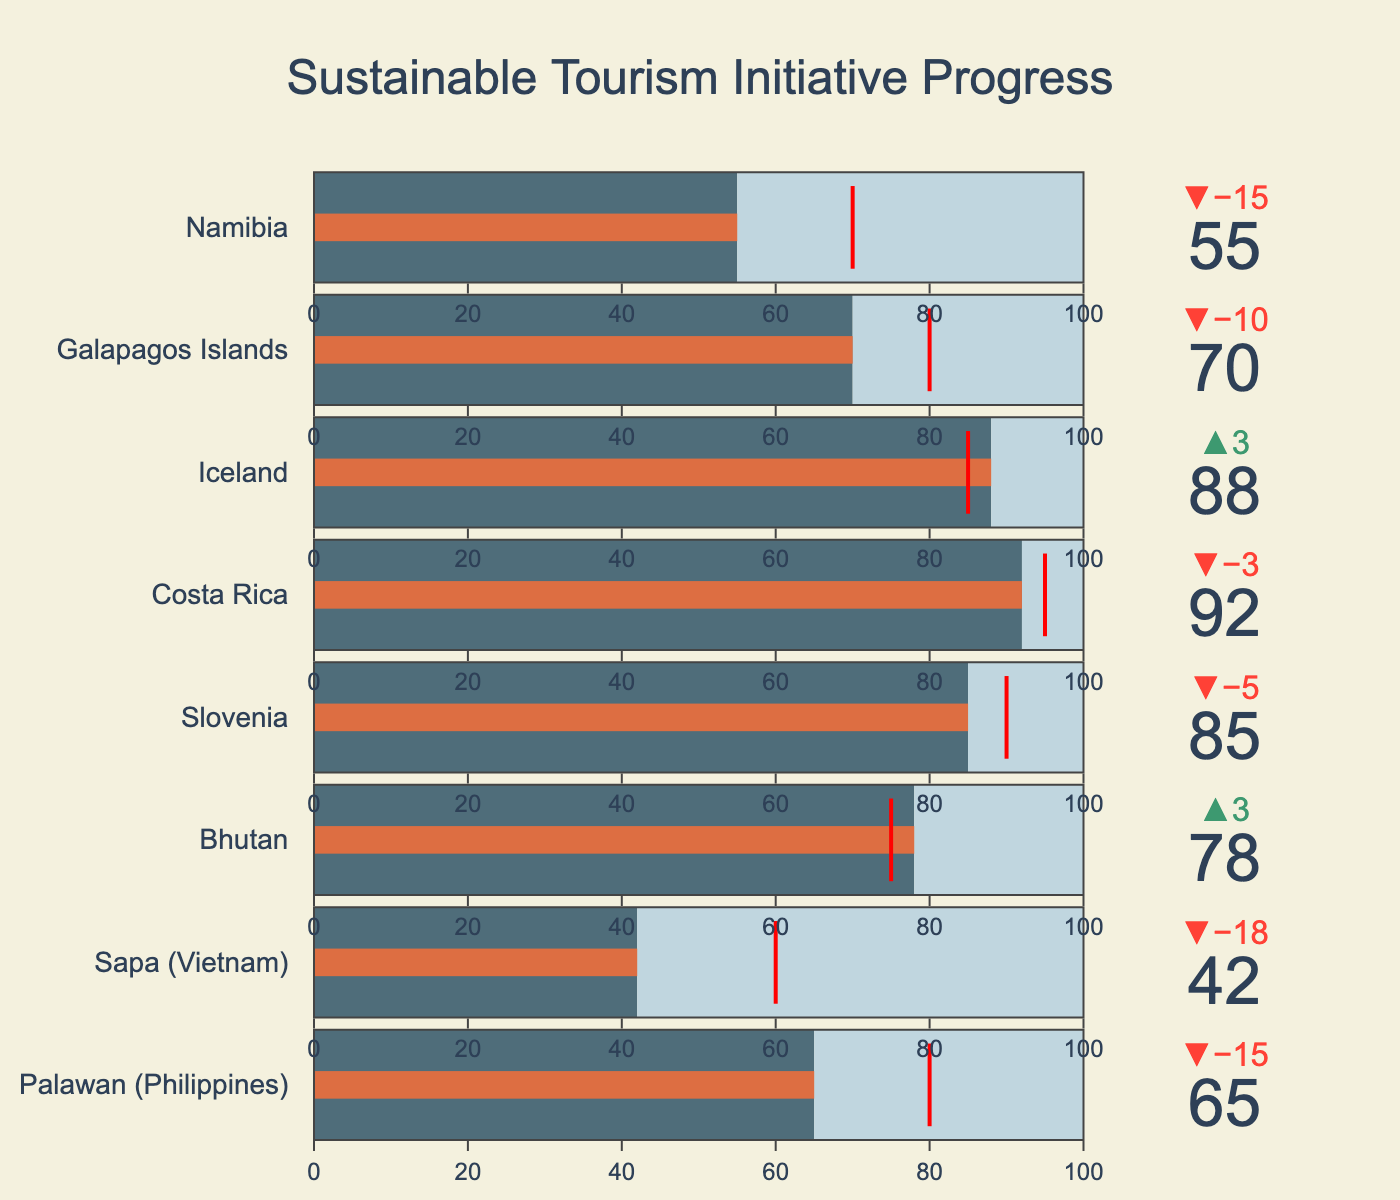What's the title of the chart? The title of the chart is typically displayed prominently at the top. By looking at the figure, the title is given as "Sustainable Tourism Initiative Progress".
Answer: Sustainable Tourism Initiative Progress Which destination has the highest actual progress? By examining the values of actual progress for each destination, Costa Rica has the highest actual progress at 92.
Answer: Costa Rica Which destination did not meet its target? Destinations that did not meet their targets have actual progress values less than their target values. These destinations are Palawan, Sapa, Galapagos Islands, and Namibia.
Answer: Palawan, Sapa, Galapagos Islands, Namibia How much more progress does Palawan need to meet its target? The progress Palawan needs to meet its target is the difference between the target and the actual progress. Therefore, it's 80 - 65 = 15.
Answer: 15 What is the average target value across all destinations? The target values are 80, 60, 75, 90, 95, 85, 80, and 70. Their sum is 635, and there are 8 destinations. So, the average target is 635 / 8 = 79.375.
Answer: 79.375 Which destination exceeds its target by the largest margin? By comparing actual progress to target values, the destination exceeding its target by the largest margin is Iceland, with an actual progress of 88 compared to a target of 85. The difference is 3.
Answer: Iceland By how much did Bhutan exceed its target? The difference between Bhutan's actual progress (78) and its target (75) is 78 - 75 = 3.
Answer: 3 Arrange the destinations in descending order of actual progress. The destinations can be ordered by their actual progress values as follows: Costa Rica (92), Iceland (88), Slovenia (85), Bhutan (78), Galapagos Islands (70), Palawan (65), Namibia (55), Sapa (42).
Answer: Costa Rica, Iceland, Slovenia, Bhutan, Galapagos Islands, Palawan, Namibia, Sapa Which destination has an actual progress value closest to its target? By calculating the difference between actual progress and target for each destination, Iceland is closest to its target with a difference of 3 (88 - 85).
Answer: Iceland 